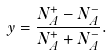<formula> <loc_0><loc_0><loc_500><loc_500>y = \frac { N _ { A } ^ { + } - N _ { A } ^ { - } } { N _ { A } ^ { + } + N _ { A } ^ { - } } .</formula> 